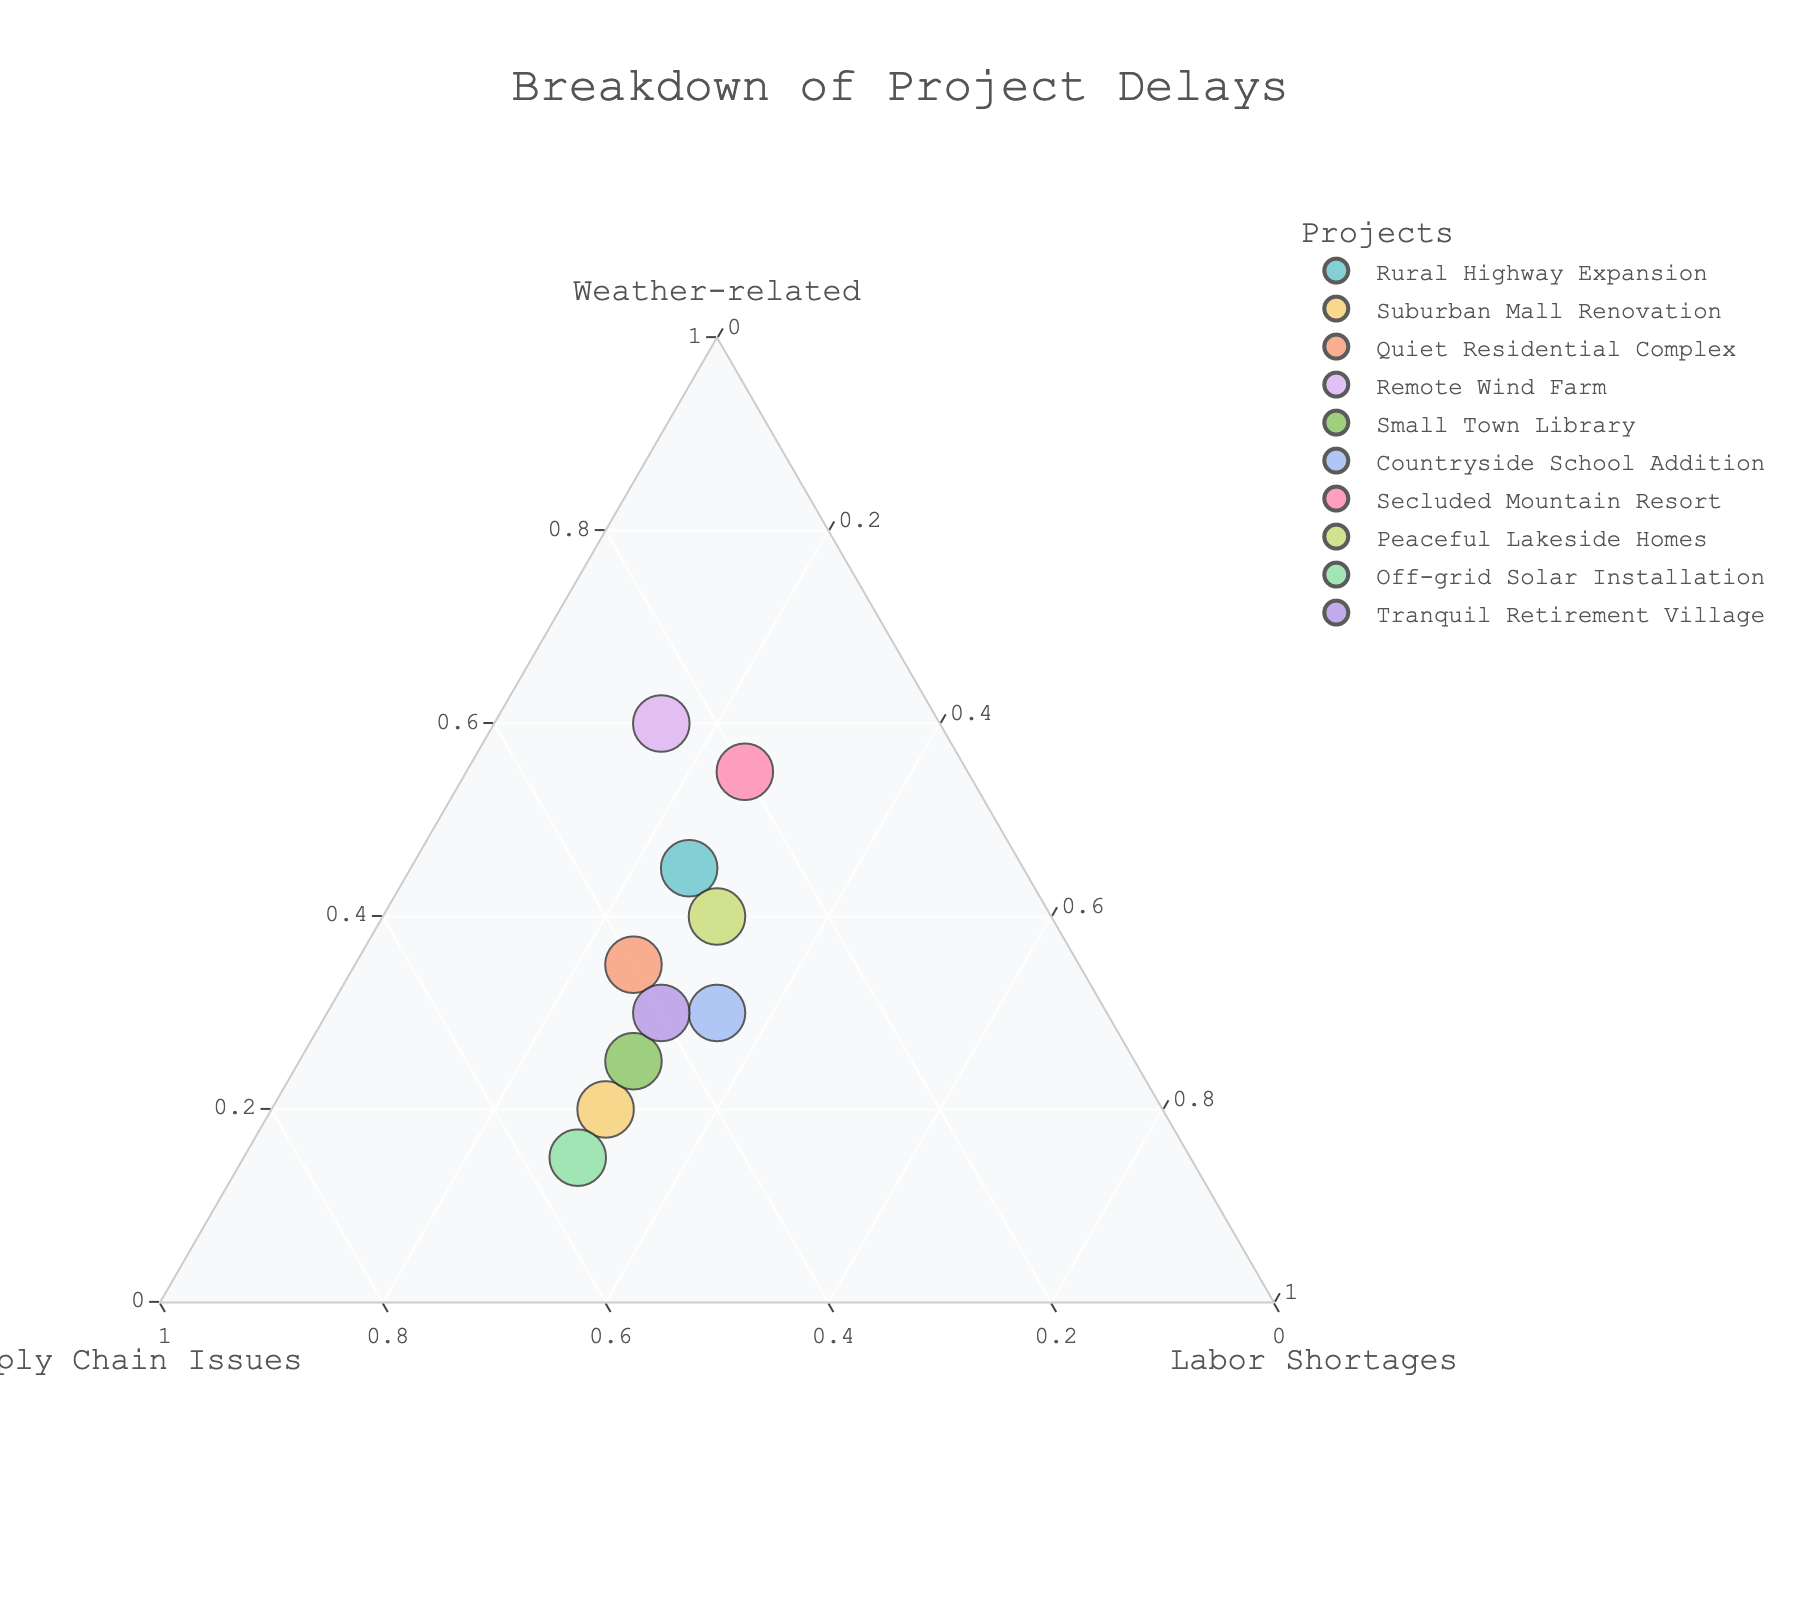what is the title of the plot? Look at the top center part of the figure where the title is usually displayed.
Answer: Breakdown of Project Delays how many projects are being compared in the plot? Count the number of data points (markers) in the ternary plot.
Answer: 10 which project has the highest proportion of weather-related delays? Identify the data point furthest towards the "Weather-related" axis.
Answer: Remote Wind Farm which project has the smallest proportion of supply chain issues? Identify the data point furthest from the "Supply Chain Issues" axis.
Answer: Remote Wind Farm compare the proportions of weather-related delays for Rural Highway Expansion and Secluded Mountain Resort. Which one is higher? Look at the positions of the two data points along the "Weather-related" axis and compare.
Answer: Secluded Mountain Resort which project has an equal distribution of all three delay types (weather-related, supply chain issues, labor shortages)? Find the data point located closest to the center of the ternary plot where all three axes intersect.
Answer: Countryside School Addition which project has a higher proportion of labor shortages: Tranquil Retirement Village or Small Town Library? Compare the positions of Tranquil Retirement Village and Small Town Library data points along the "Labor Shortages" axis.
Answer: Small Town Library what is the range of supply chain issue proportions among all the projects? Identify the minimum and maximum values on the "Supply Chain Issues" axis and calculate the range.
Answer: 20 to 55 what trends or patterns can you observe in the causes of delays for projects located in less bustling vs. more bustling areas? Compare the locations of projects like Remote Wind Farm and Secluded Mountain Resort with those like Suburban Mall Renovation and Small Town Library. Identify any commonalities in delay causes.
Answer: Less bustling areas tend to have higher weather-related delays and lower supply chain issues calculate the average proportion of labor shortages across all projects. Sum the "Labor Shortages" proportions, then divide by the number of projects. ((25+30+25+15+30+35+25+30+30+30)/10)
Answer: 27.5% 